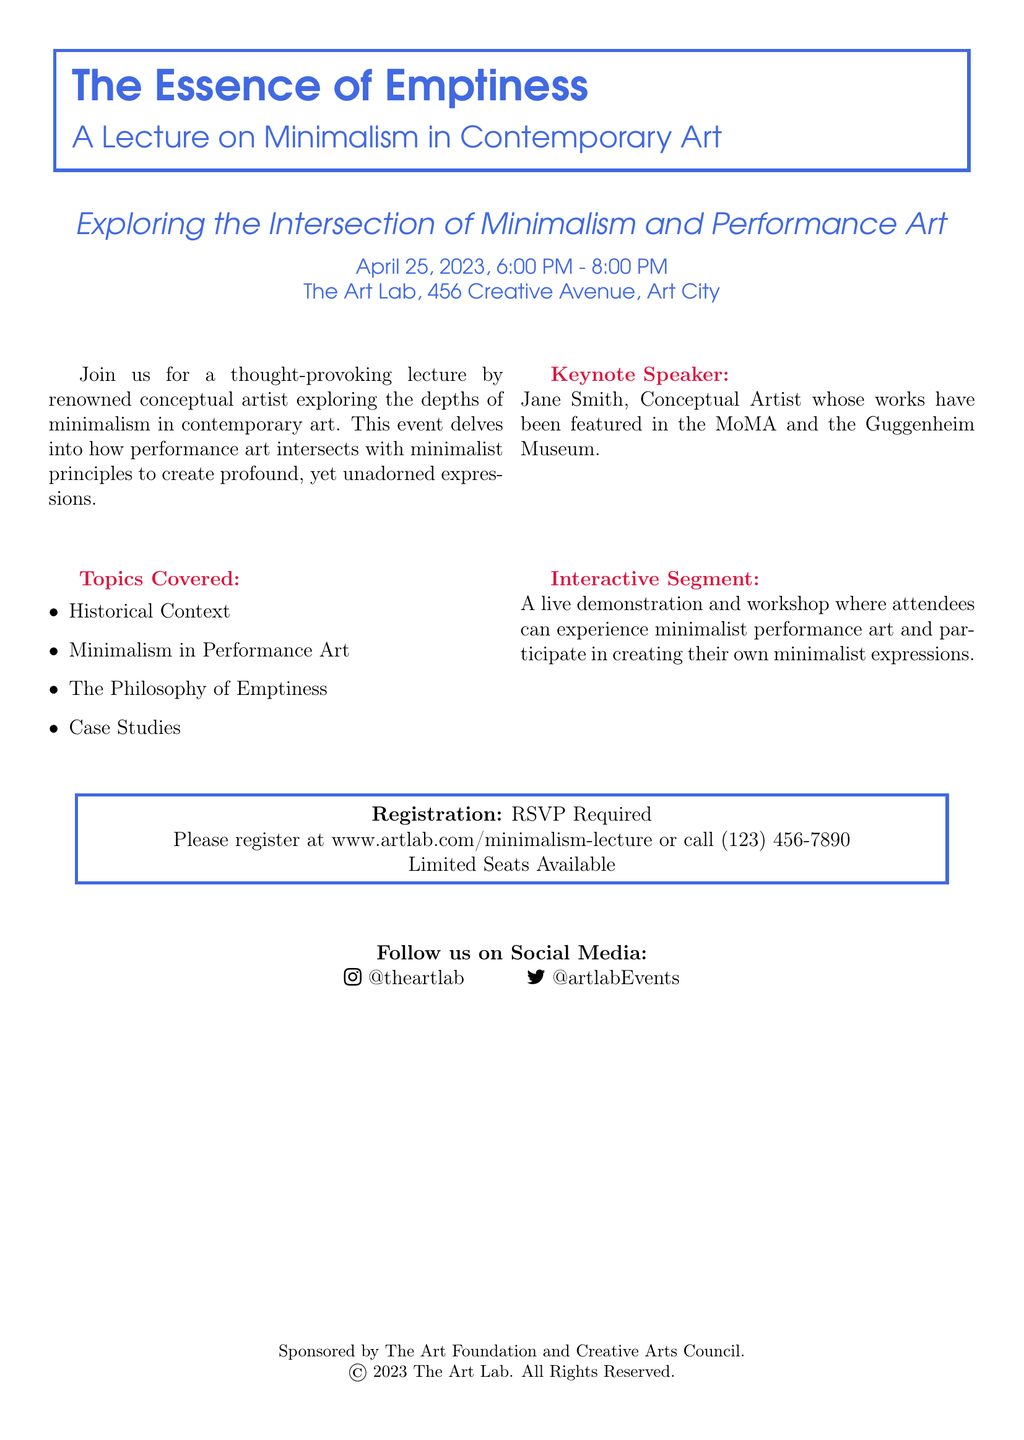What is the title of the lecture? The title is prominently displayed at the top of the flyer.
Answer: The Essence of Emptiness Who is the keynote speaker? The speaker is mentioned in the section about the lecture.
Answer: Jane Smith What date is the lecture scheduled for? The date is indicated below the title of the lecture.
Answer: April 25, 2023 What time does the lecture start? The start time is listed next to the date in the document.
Answer: 6:00 PM What is one of the topics covered in the lecture? The topics are listed in a bullet format in the document.
Answer: Historical Context Is there an interactive segment? The document outlines whether this event has an interactive component.
Answer: Yes Where can attendees register for the event? The registration details are provided towards the end of the document.
Answer: www.artlab.com/minimalism-lecture How long is the lecture scheduled to last? The duration is indicated alongside the starting time.
Answer: 2 hours 